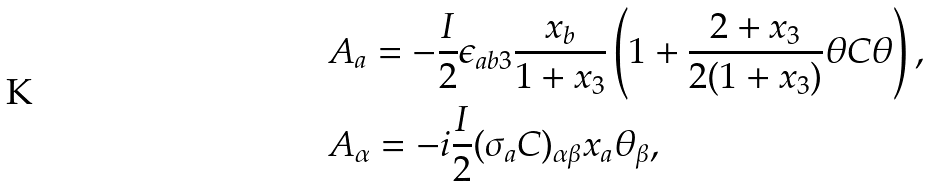Convert formula to latex. <formula><loc_0><loc_0><loc_500><loc_500>& A _ { a } = - \frac { I } { 2 } \epsilon _ { a b 3 } \frac { x _ { b } } { 1 + x _ { 3 } } \left ( 1 + \frac { 2 + x _ { 3 } } { 2 ( 1 + x _ { 3 } ) } \theta C \theta \right ) , \\ & A _ { \alpha } = - i \frac { I } { 2 } ( \sigma _ { a } C ) _ { \alpha \beta } x _ { a } \theta _ { \beta } ,</formula> 